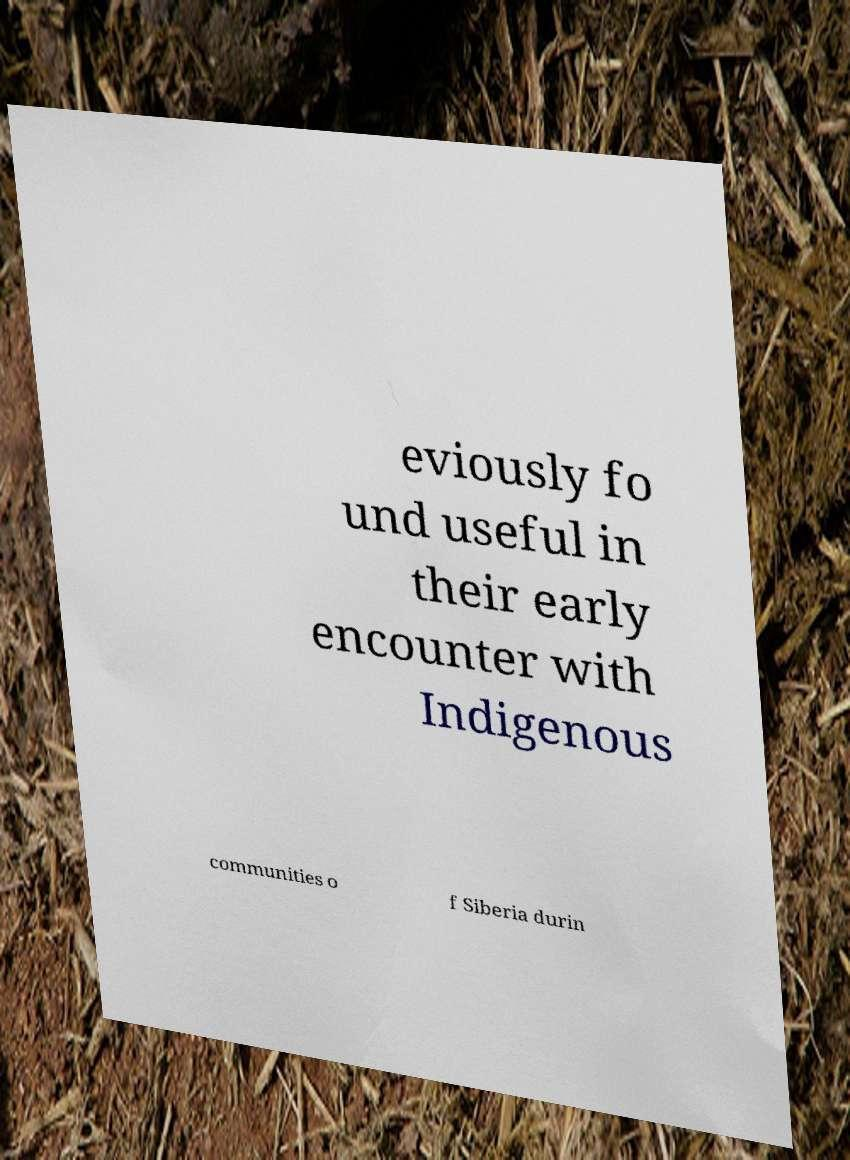What messages or text are displayed in this image? I need them in a readable, typed format. eviously fo und useful in their early encounter with Indigenous communities o f Siberia durin 